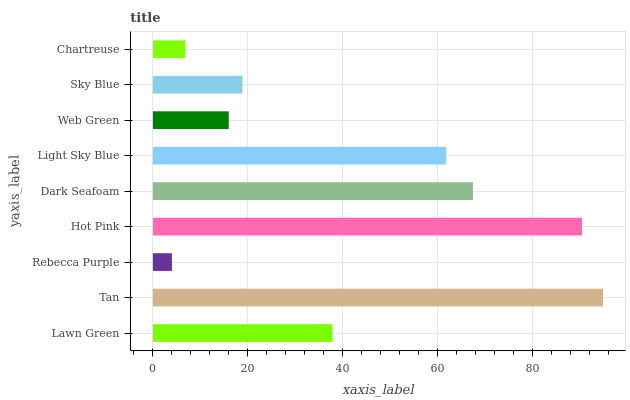Is Rebecca Purple the minimum?
Answer yes or no. Yes. Is Tan the maximum?
Answer yes or no. Yes. Is Tan the minimum?
Answer yes or no. No. Is Rebecca Purple the maximum?
Answer yes or no. No. Is Tan greater than Rebecca Purple?
Answer yes or no. Yes. Is Rebecca Purple less than Tan?
Answer yes or no. Yes. Is Rebecca Purple greater than Tan?
Answer yes or no. No. Is Tan less than Rebecca Purple?
Answer yes or no. No. Is Lawn Green the high median?
Answer yes or no. Yes. Is Lawn Green the low median?
Answer yes or no. Yes. Is Light Sky Blue the high median?
Answer yes or no. No. Is Sky Blue the low median?
Answer yes or no. No. 